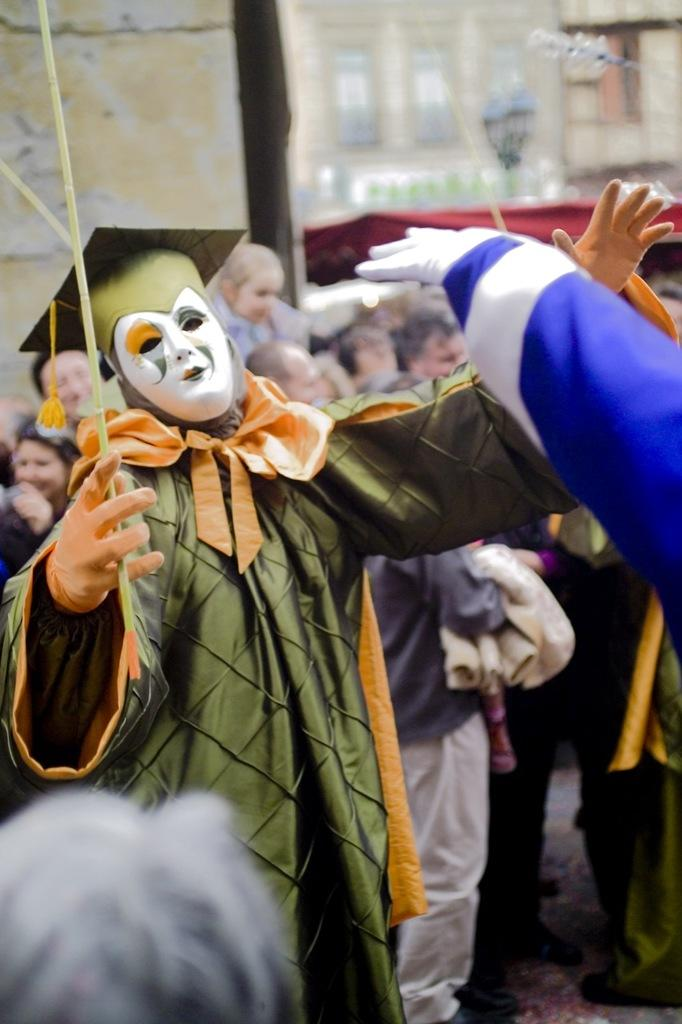How many people are in the image? There are two people in the image. What are the two people wearing? The two people are wearing different costumes. What are the two people doing in the image? The two people are performing an action. What is the reaction of the people around them? There is a crowd in the image, and they are watching the performance. What type of song is being sung by the two people in the image? There is no indication in the image that the two people are singing a song. 